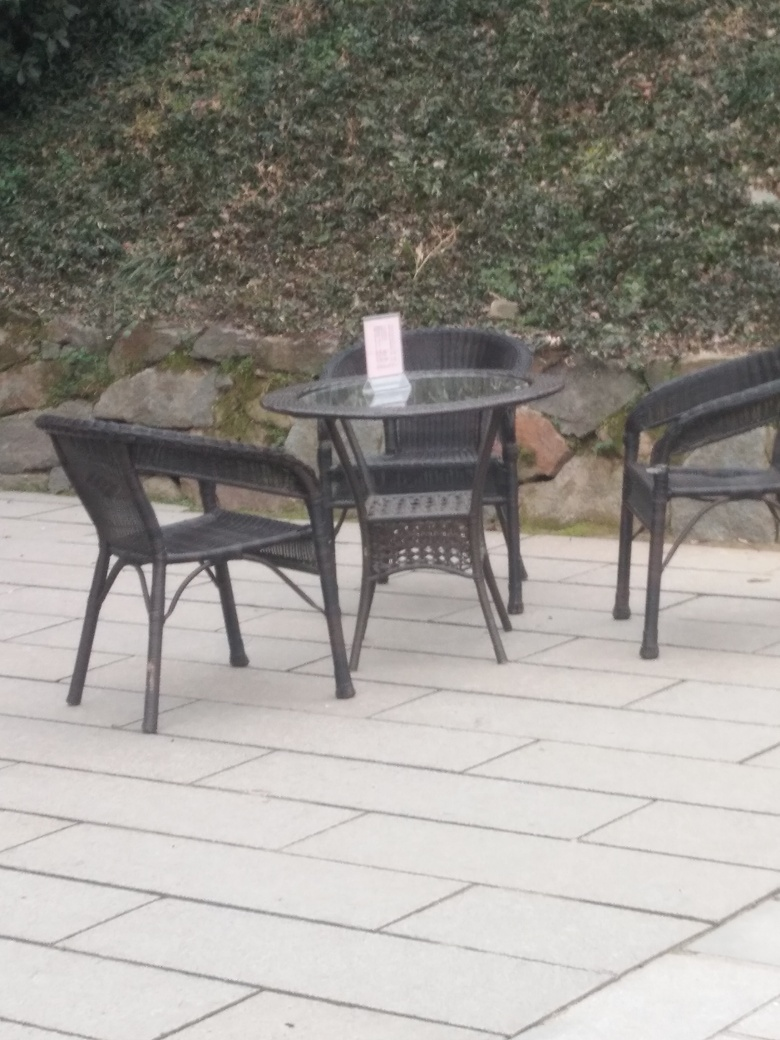What time of day does this image seem to represent? Though there is no direct sunlight, the natural light present suggests it could be either midday on an overcast day or possibly late afternoon. There are no long shadows or warm light that typically represent morning or late evening hours. 